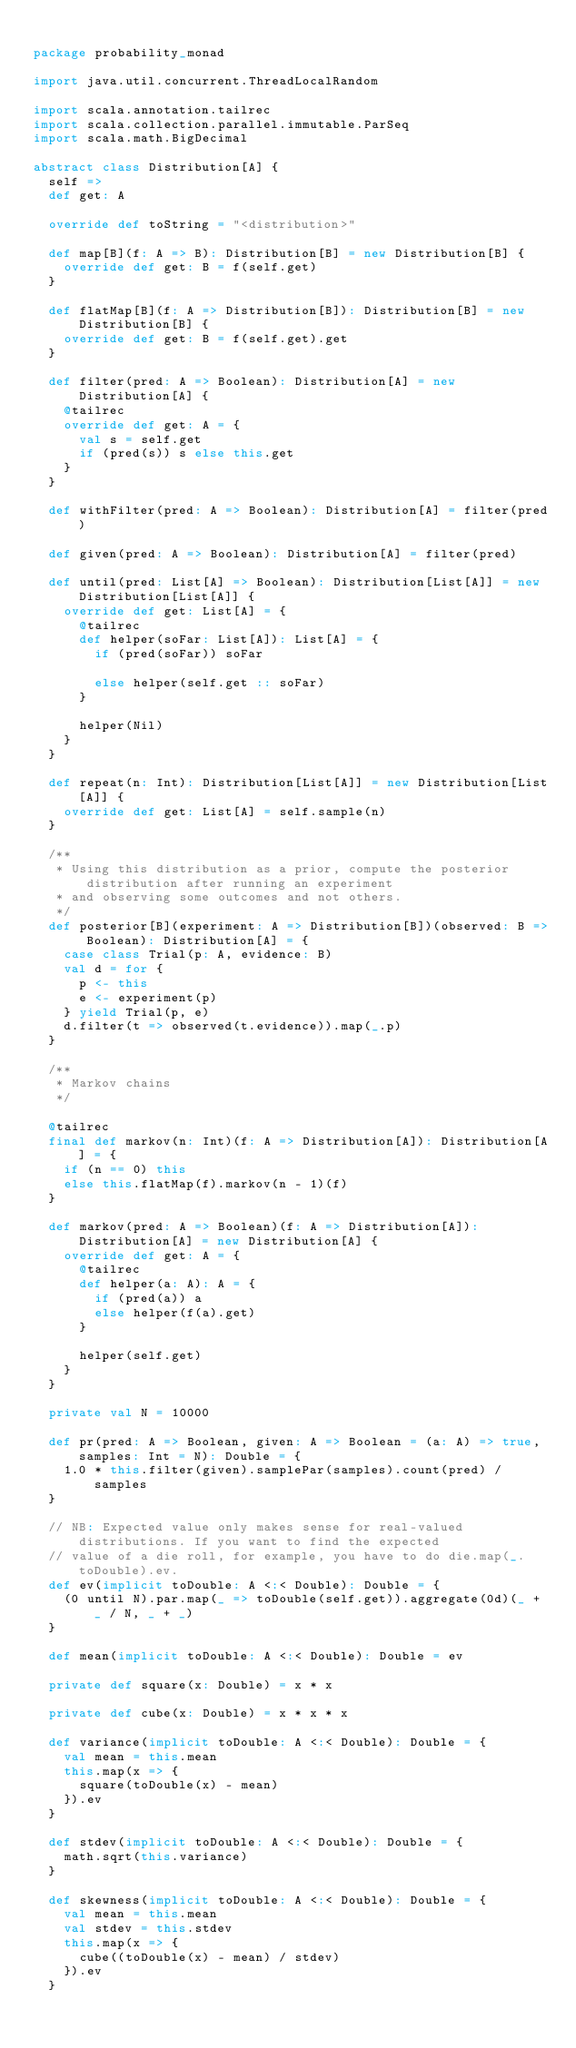<code> <loc_0><loc_0><loc_500><loc_500><_Scala_>
package probability_monad

import java.util.concurrent.ThreadLocalRandom

import scala.annotation.tailrec
import scala.collection.parallel.immutable.ParSeq
import scala.math.BigDecimal

abstract class Distribution[A] {
  self =>
  def get: A
  
  override def toString = "<distribution>"
  
  def map[B](f: A => B): Distribution[B] = new Distribution[B] {
    override def get: B = f(self.get)
  }
  
  def flatMap[B](f: A => Distribution[B]): Distribution[B] = new Distribution[B] {
    override def get: B = f(self.get).get
  }
  
  def filter(pred: A => Boolean): Distribution[A] = new Distribution[A] {
    @tailrec
    override def get: A = {
      val s = self.get
      if (pred(s)) s else this.get
    }
  }
  
  def withFilter(pred: A => Boolean): Distribution[A] = filter(pred)
  
  def given(pred: A => Boolean): Distribution[A] = filter(pred)
  
  def until(pred: List[A] => Boolean): Distribution[List[A]] = new Distribution[List[A]] {
    override def get: List[A] = {
      @tailrec
      def helper(soFar: List[A]): List[A] = {
        if (pred(soFar)) soFar
        
        else helper(self.get :: soFar)
      }
      
      helper(Nil)
    }
  }
  
  def repeat(n: Int): Distribution[List[A]] = new Distribution[List[A]] {
    override def get: List[A] = self.sample(n)
  }
  
  /**
   * Using this distribution as a prior, compute the posterior distribution after running an experiment
   * and observing some outcomes and not others.
   */
  def posterior[B](experiment: A => Distribution[B])(observed: B => Boolean): Distribution[A] = {
    case class Trial(p: A, evidence: B)
    val d = for {
      p <- this
      e <- experiment(p)
    } yield Trial(p, e)
    d.filter(t => observed(t.evidence)).map(_.p)
  }
  
  /**
   * Markov chains
   */
  
  @tailrec
  final def markov(n: Int)(f: A => Distribution[A]): Distribution[A] = {
    if (n == 0) this
    else this.flatMap(f).markov(n - 1)(f)
  }
  
  def markov(pred: A => Boolean)(f: A => Distribution[A]): Distribution[A] = new Distribution[A] {
    override def get: A = {
      @tailrec
      def helper(a: A): A = {
        if (pred(a)) a
        else helper(f(a).get)
      }
      
      helper(self.get)
    }
  }
  
  private val N = 10000
  
  def pr(pred: A => Boolean, given: A => Boolean = (a: A) => true, samples: Int = N): Double = {
    1.0 * this.filter(given).samplePar(samples).count(pred) / samples
  }
  
  // NB: Expected value only makes sense for real-valued distributions. If you want to find the expected
  // value of a die roll, for example, you have to do die.map(_.toDouble).ev.
  def ev(implicit toDouble: A <:< Double): Double = {
    (0 until N).par.map(_ => toDouble(self.get)).aggregate(0d)(_ + _ / N, _ + _)
  }
  
  def mean(implicit toDouble: A <:< Double): Double = ev
  
  private def square(x: Double) = x * x
  
  private def cube(x: Double) = x * x * x
  
  def variance(implicit toDouble: A <:< Double): Double = {
    val mean = this.mean
    this.map(x => {
      square(toDouble(x) - mean)
    }).ev
  }
  
  def stdev(implicit toDouble: A <:< Double): Double = {
    math.sqrt(this.variance)
  }
  
  def skewness(implicit toDouble: A <:< Double): Double = {
    val mean = this.mean
    val stdev = this.stdev
    this.map(x => {
      cube((toDouble(x) - mean) / stdev)
    }).ev
  }
  </code> 